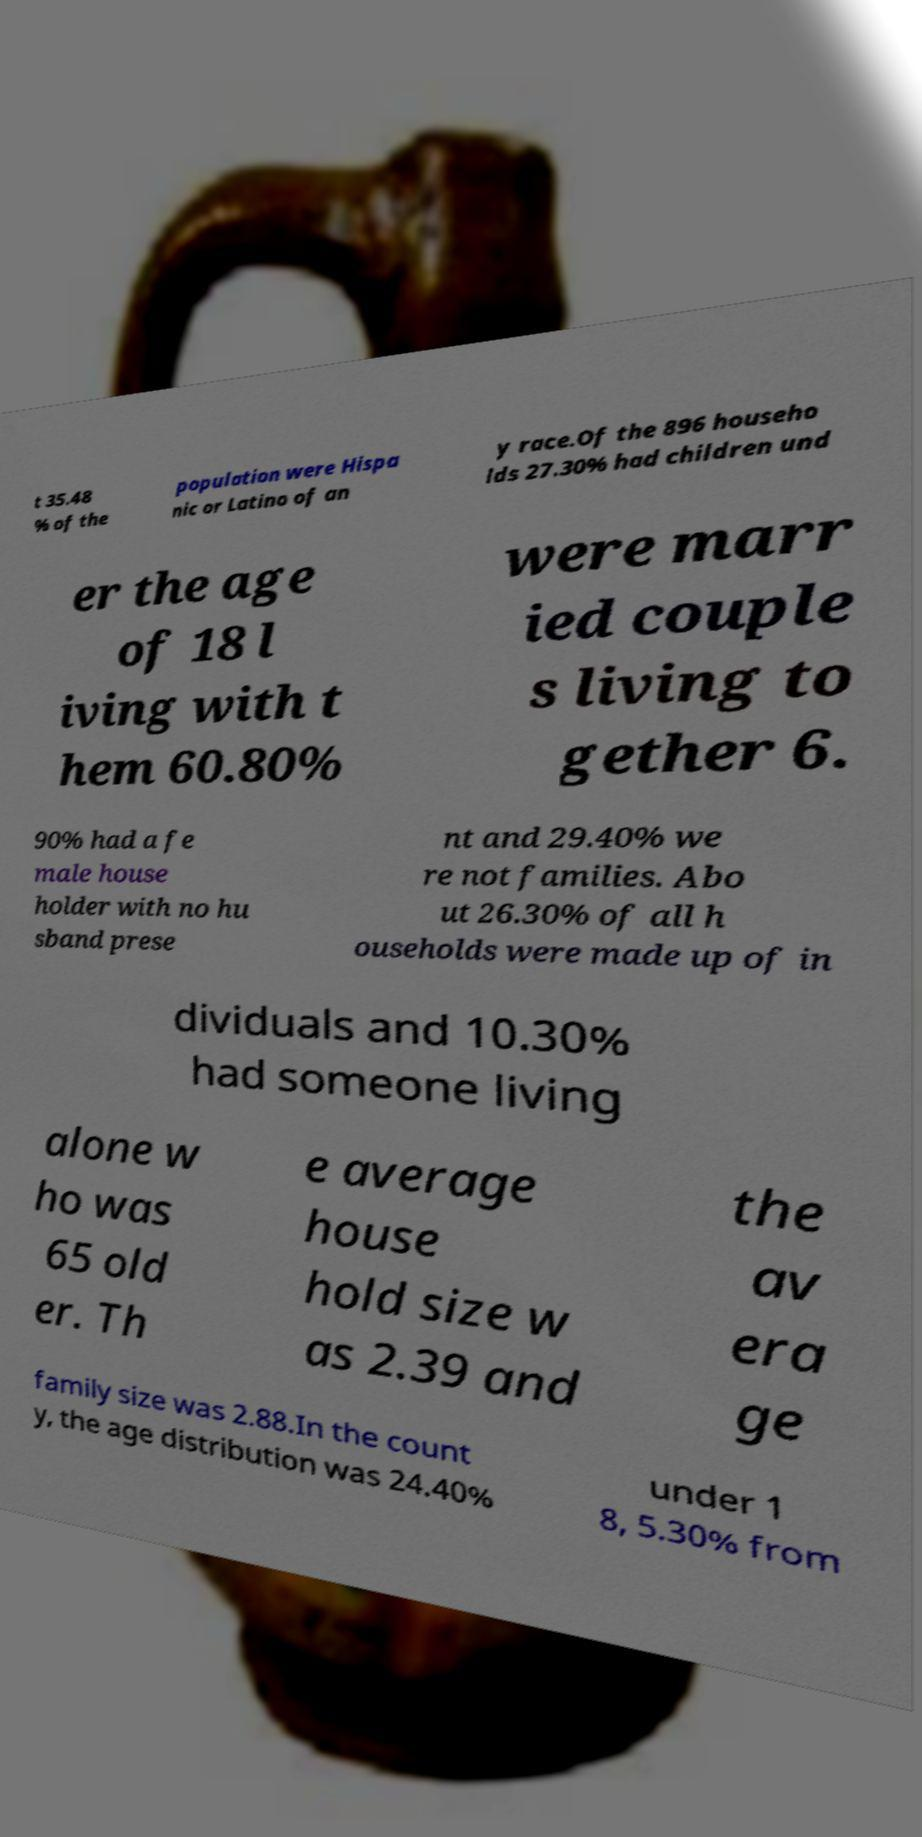There's text embedded in this image that I need extracted. Can you transcribe it verbatim? t 35.48 % of the population were Hispa nic or Latino of an y race.Of the 896 househo lds 27.30% had children und er the age of 18 l iving with t hem 60.80% were marr ied couple s living to gether 6. 90% had a fe male house holder with no hu sband prese nt and 29.40% we re not families. Abo ut 26.30% of all h ouseholds were made up of in dividuals and 10.30% had someone living alone w ho was 65 old er. Th e average house hold size w as 2.39 and the av era ge family size was 2.88.In the count y, the age distribution was 24.40% under 1 8, 5.30% from 